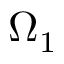Convert formula to latex. <formula><loc_0><loc_0><loc_500><loc_500>\Omega _ { 1 }</formula> 